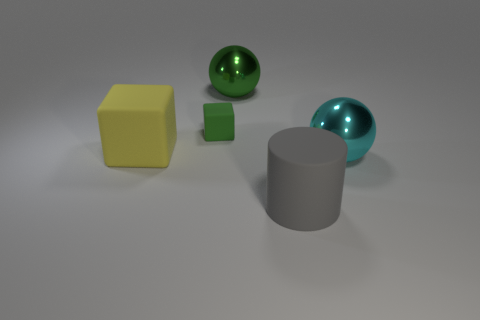Add 5 green matte objects. How many objects exist? 10 Subtract all cubes. How many objects are left? 3 Subtract all green blocks. Subtract all rubber cylinders. How many objects are left? 3 Add 2 yellow matte blocks. How many yellow matte blocks are left? 3 Add 1 tiny brown matte blocks. How many tiny brown matte blocks exist? 1 Subtract 0 gray spheres. How many objects are left? 5 